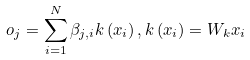<formula> <loc_0><loc_0><loc_500><loc_500>o _ { j } = \sum _ { i = 1 } ^ { N } \beta _ { j , i } k \left ( x _ { i } \right ) , k \left ( x _ { i } \right ) = W _ { k } x _ { i }</formula> 